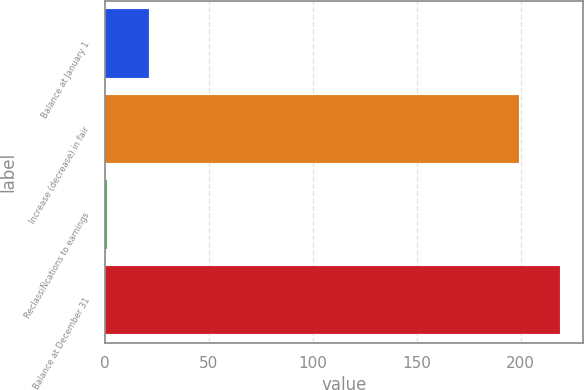Convert chart. <chart><loc_0><loc_0><loc_500><loc_500><bar_chart><fcel>Balance at January 1<fcel>Increase (decrease) in fair<fcel>ReclassiÑcations to earnings<fcel>Balance at December 31<nl><fcel>21.1<fcel>199<fcel>1<fcel>219.1<nl></chart> 